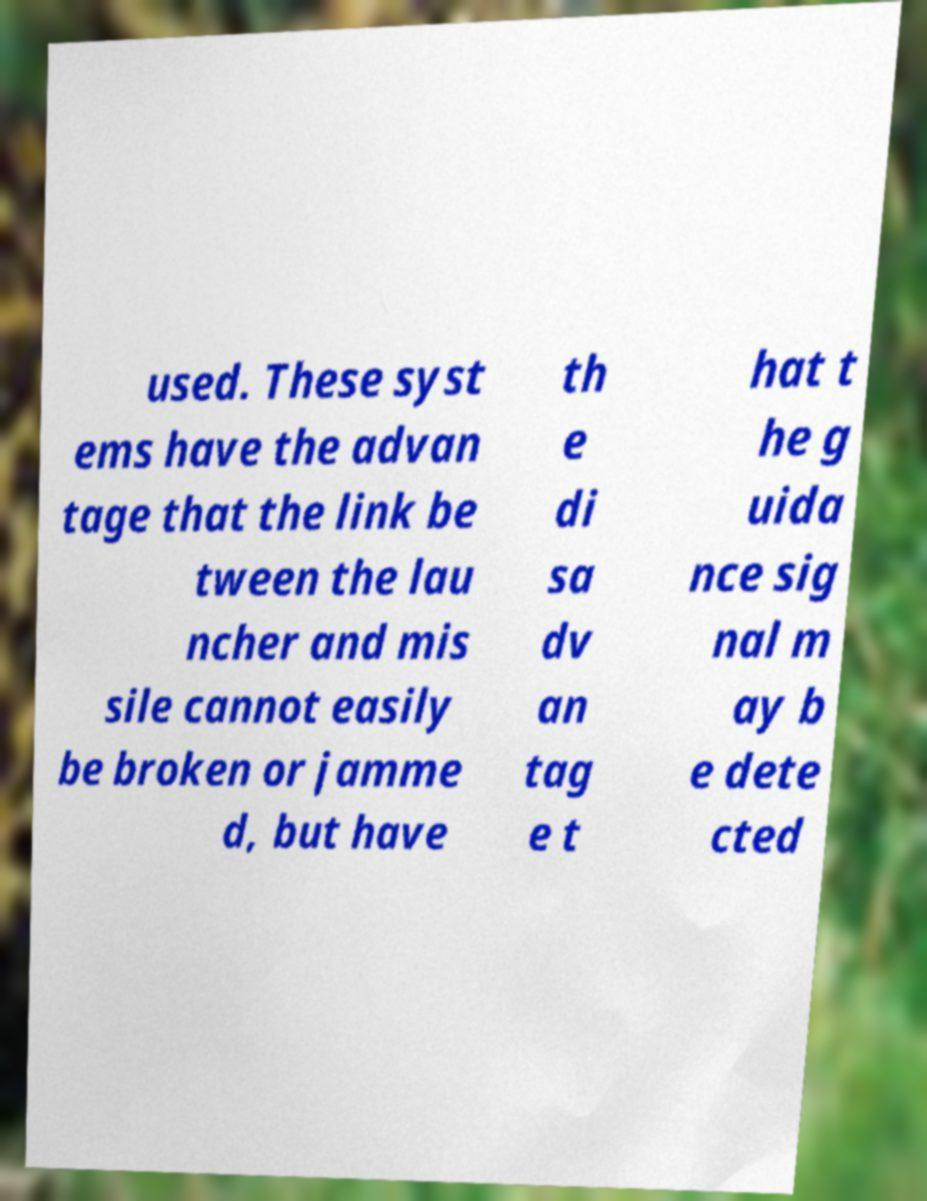Please identify and transcribe the text found in this image. used. These syst ems have the advan tage that the link be tween the lau ncher and mis sile cannot easily be broken or jamme d, but have th e di sa dv an tag e t hat t he g uida nce sig nal m ay b e dete cted 